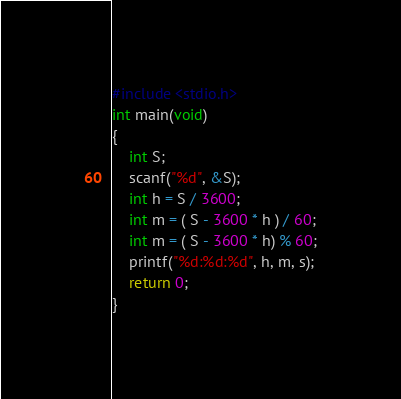Convert code to text. <code><loc_0><loc_0><loc_500><loc_500><_C_>#include <stdio.h>
int main(void)
{
    int S;
    scanf("%d", &S);
    int h = S / 3600;
    int m = ( S - 3600 * h ) / 60;
    int m = ( S - 3600 * h) % 60;
    printf("%d:%d:%d", h, m, s);
    return 0;
}
</code> 